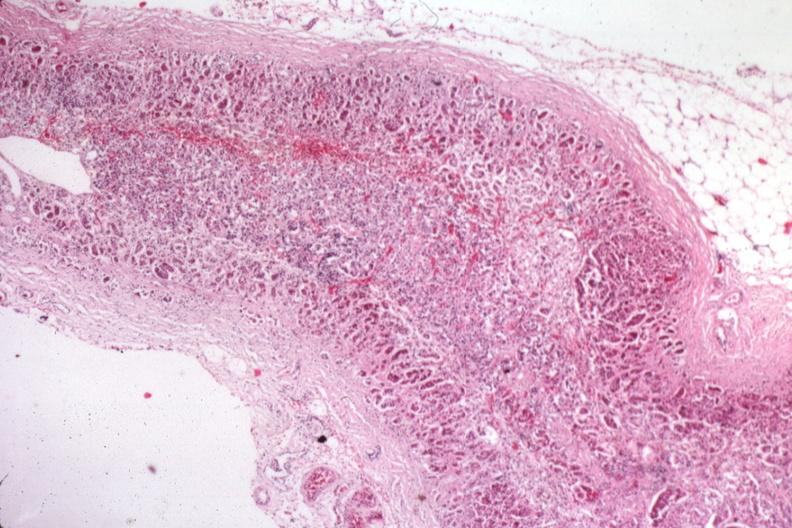where is this part in the figure?
Answer the question using a single word or phrase. Endocrine system 